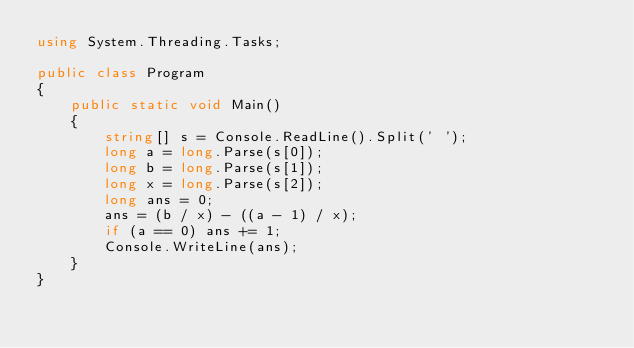Convert code to text. <code><loc_0><loc_0><loc_500><loc_500><_C#_>using System.Threading.Tasks;

public class Program
{
    public static void Main()
    {
        string[] s = Console.ReadLine().Split(' ');
        long a = long.Parse(s[0]);
        long b = long.Parse(s[1]);
        long x = long.Parse(s[2]);
        long ans = 0;
        ans = (b / x) - ((a - 1) / x);
        if (a == 0) ans += 1;
        Console.WriteLine(ans);
    }
}
</code> 